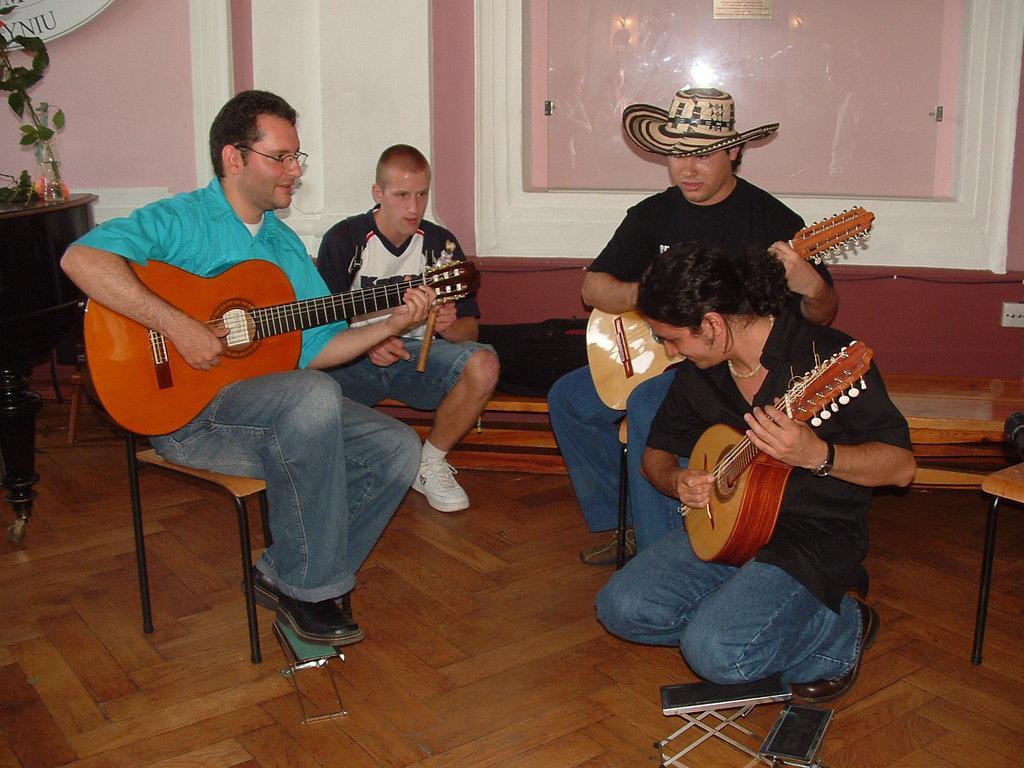How would you summarize this image in a sentence or two? Here we can see four people who are sitting and three of them all playing guitar the person in the middle is wearing a hat and beside him we can see a person sitting and there is a plant present 